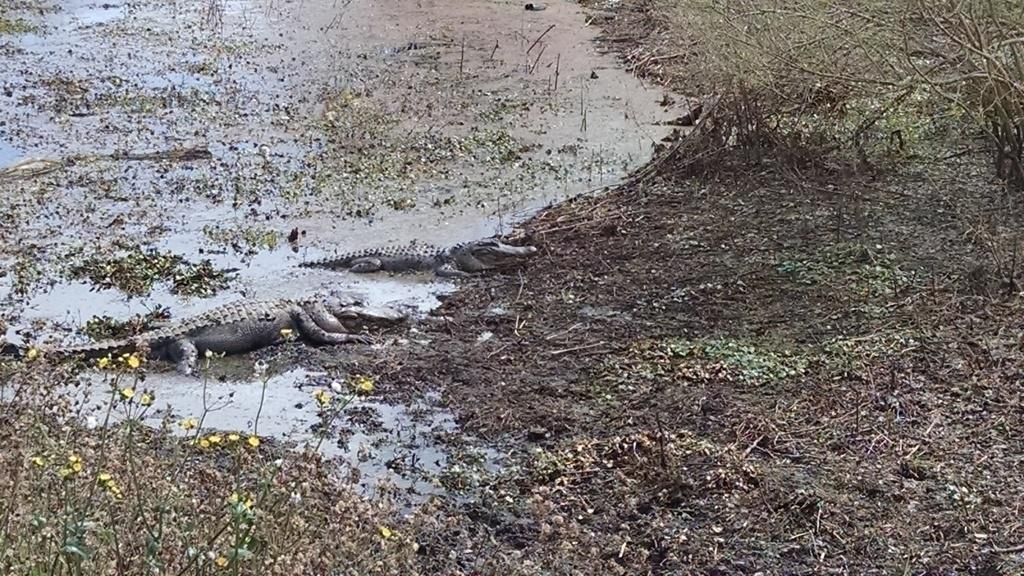What type of animals can be seen in the water in the image? There are crocodiles in the water in the image. What celestial bodies are visible in the image? There are planets visible in the image. What type of vegetation can be seen in the image? There is grass in the image. What type of balls can be seen rolling on the grass in the image? There are no balls present in the image; it features crocodiles in the water and planets. Is there a maid visible in the image? There is no maid present in the image. 